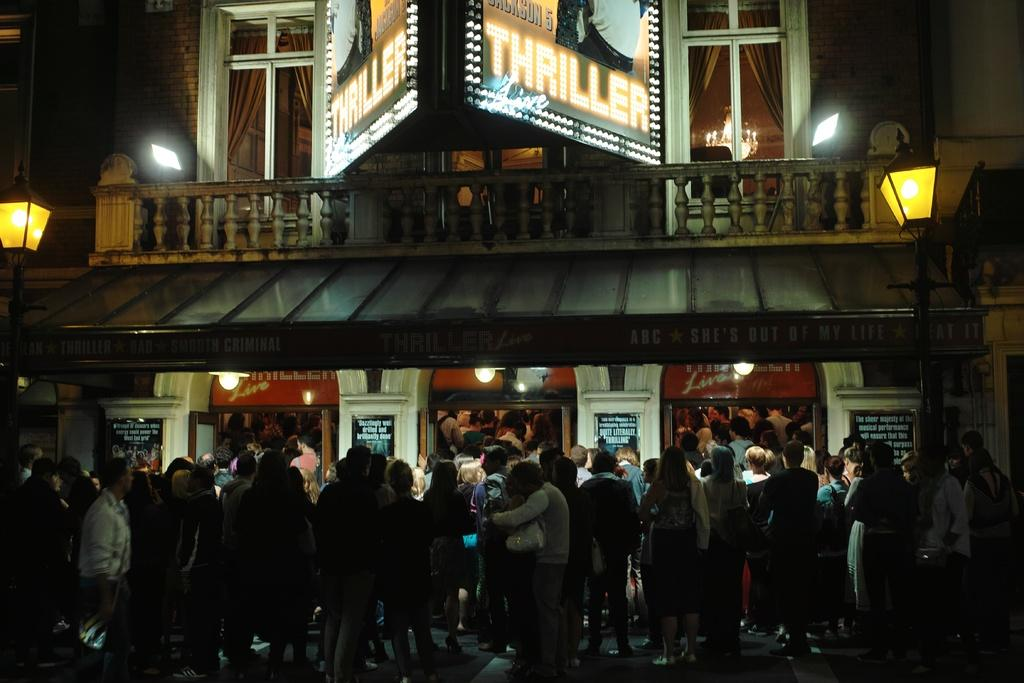<image>
Render a clear and concise summary of the photo. People are standing in line to see Thriller Live. 